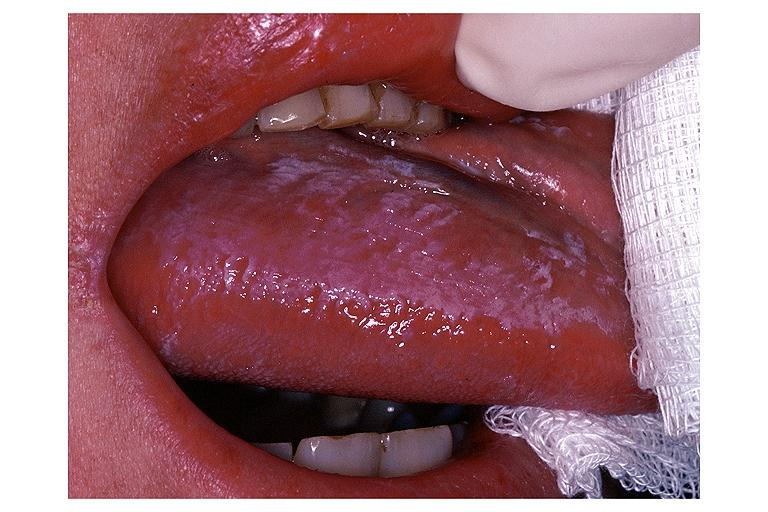s oral present?
Answer the question using a single word or phrase. Yes 